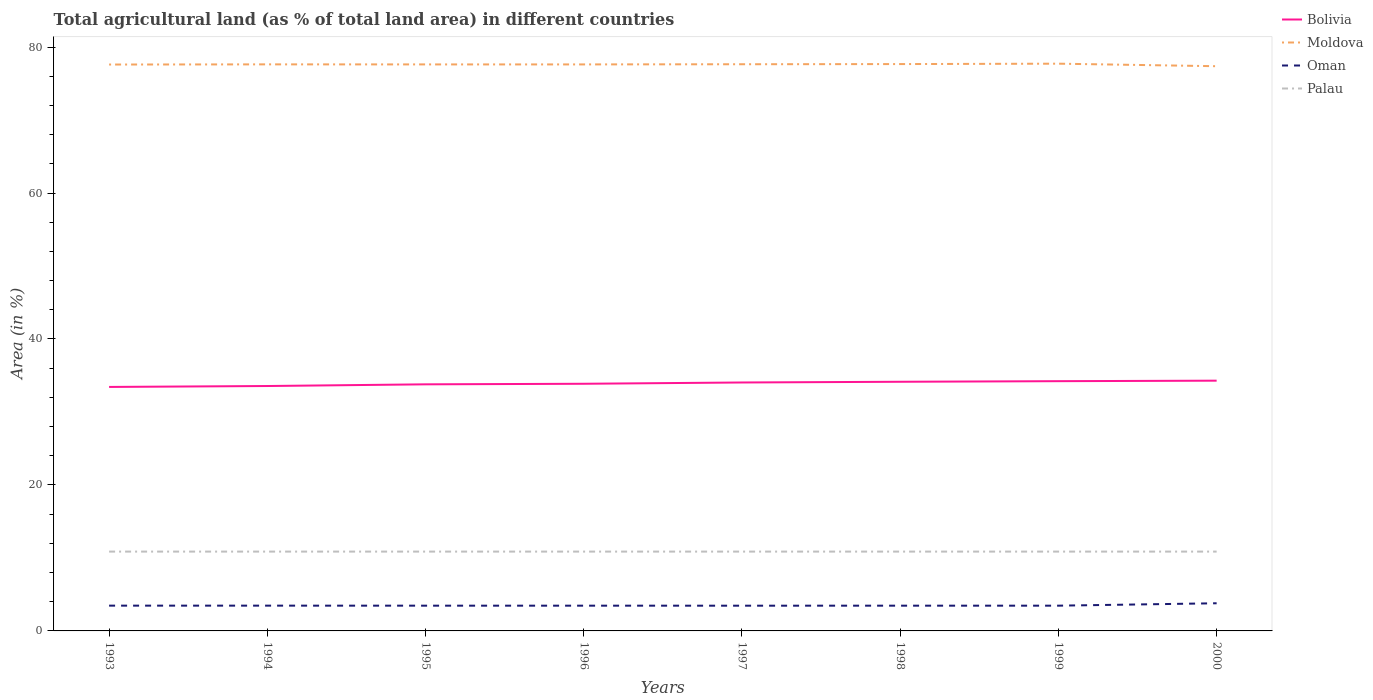Is the number of lines equal to the number of legend labels?
Ensure brevity in your answer.  Yes. Across all years, what is the maximum percentage of agricultural land in Bolivia?
Make the answer very short. 33.43. In which year was the percentage of agricultural land in Moldova maximum?
Offer a terse response. 2000. What is the total percentage of agricultural land in Oman in the graph?
Provide a short and direct response. -0. What is the difference between the highest and the second highest percentage of agricultural land in Moldova?
Provide a short and direct response. 0.35. Is the percentage of agricultural land in Bolivia strictly greater than the percentage of agricultural land in Palau over the years?
Your response must be concise. No. How many lines are there?
Give a very brief answer. 4. How many years are there in the graph?
Provide a short and direct response. 8. What is the difference between two consecutive major ticks on the Y-axis?
Keep it short and to the point. 20. Are the values on the major ticks of Y-axis written in scientific E-notation?
Provide a short and direct response. No. Where does the legend appear in the graph?
Provide a succinct answer. Top right. How are the legend labels stacked?
Ensure brevity in your answer.  Vertical. What is the title of the graph?
Keep it short and to the point. Total agricultural land (as % of total land area) in different countries. Does "Latin America(all income levels)" appear as one of the legend labels in the graph?
Your answer should be compact. No. What is the label or title of the X-axis?
Your response must be concise. Years. What is the label or title of the Y-axis?
Offer a terse response. Area (in %). What is the Area (in %) in Bolivia in 1993?
Give a very brief answer. 33.43. What is the Area (in %) in Moldova in 1993?
Your answer should be compact. 77.6. What is the Area (in %) of Oman in 1993?
Offer a very short reply. 3.46. What is the Area (in %) of Palau in 1993?
Offer a terse response. 10.87. What is the Area (in %) in Bolivia in 1994?
Ensure brevity in your answer.  33.56. What is the Area (in %) in Moldova in 1994?
Your answer should be compact. 77.63. What is the Area (in %) of Oman in 1994?
Ensure brevity in your answer.  3.46. What is the Area (in %) of Palau in 1994?
Offer a terse response. 10.87. What is the Area (in %) in Bolivia in 1995?
Your answer should be very brief. 33.79. What is the Area (in %) of Moldova in 1995?
Give a very brief answer. 77.62. What is the Area (in %) in Oman in 1995?
Provide a short and direct response. 3.46. What is the Area (in %) in Palau in 1995?
Offer a very short reply. 10.87. What is the Area (in %) of Bolivia in 1996?
Keep it short and to the point. 33.86. What is the Area (in %) of Moldova in 1996?
Your answer should be very brief. 77.62. What is the Area (in %) of Oman in 1996?
Offer a very short reply. 3.46. What is the Area (in %) of Palau in 1996?
Provide a short and direct response. 10.87. What is the Area (in %) of Bolivia in 1997?
Your answer should be very brief. 34.04. What is the Area (in %) of Moldova in 1997?
Offer a terse response. 77.64. What is the Area (in %) of Oman in 1997?
Offer a very short reply. 3.46. What is the Area (in %) in Palau in 1997?
Give a very brief answer. 10.87. What is the Area (in %) of Bolivia in 1998?
Give a very brief answer. 34.14. What is the Area (in %) of Moldova in 1998?
Keep it short and to the point. 77.67. What is the Area (in %) in Oman in 1998?
Offer a terse response. 3.46. What is the Area (in %) in Palau in 1998?
Keep it short and to the point. 10.87. What is the Area (in %) in Bolivia in 1999?
Your answer should be very brief. 34.22. What is the Area (in %) of Moldova in 1999?
Provide a succinct answer. 77.72. What is the Area (in %) in Oman in 1999?
Make the answer very short. 3.46. What is the Area (in %) in Palau in 1999?
Give a very brief answer. 10.87. What is the Area (in %) of Bolivia in 2000?
Provide a succinct answer. 34.29. What is the Area (in %) of Moldova in 2000?
Your answer should be very brief. 77.37. What is the Area (in %) of Oman in 2000?
Offer a very short reply. 3.79. What is the Area (in %) in Palau in 2000?
Provide a succinct answer. 10.87. Across all years, what is the maximum Area (in %) of Bolivia?
Offer a very short reply. 34.29. Across all years, what is the maximum Area (in %) of Moldova?
Your answer should be compact. 77.72. Across all years, what is the maximum Area (in %) of Oman?
Keep it short and to the point. 3.79. Across all years, what is the maximum Area (in %) of Palau?
Offer a terse response. 10.87. Across all years, what is the minimum Area (in %) of Bolivia?
Make the answer very short. 33.43. Across all years, what is the minimum Area (in %) in Moldova?
Keep it short and to the point. 77.37. Across all years, what is the minimum Area (in %) in Oman?
Your answer should be compact. 3.46. Across all years, what is the minimum Area (in %) in Palau?
Your answer should be very brief. 10.87. What is the total Area (in %) in Bolivia in the graph?
Offer a very short reply. 271.32. What is the total Area (in %) in Moldova in the graph?
Your answer should be compact. 620.87. What is the total Area (in %) of Oman in the graph?
Provide a succinct answer. 28.02. What is the total Area (in %) of Palau in the graph?
Your answer should be compact. 86.96. What is the difference between the Area (in %) in Bolivia in 1993 and that in 1994?
Keep it short and to the point. -0.13. What is the difference between the Area (in %) of Moldova in 1993 and that in 1994?
Keep it short and to the point. -0.02. What is the difference between the Area (in %) of Palau in 1993 and that in 1994?
Offer a very short reply. 0. What is the difference between the Area (in %) in Bolivia in 1993 and that in 1995?
Your answer should be compact. -0.36. What is the difference between the Area (in %) of Moldova in 1993 and that in 1995?
Give a very brief answer. -0.02. What is the difference between the Area (in %) of Oman in 1993 and that in 1995?
Offer a very short reply. 0. What is the difference between the Area (in %) of Palau in 1993 and that in 1995?
Make the answer very short. 0. What is the difference between the Area (in %) in Bolivia in 1993 and that in 1996?
Offer a terse response. -0.43. What is the difference between the Area (in %) of Moldova in 1993 and that in 1996?
Keep it short and to the point. -0.02. What is the difference between the Area (in %) of Oman in 1993 and that in 1996?
Provide a succinct answer. 0. What is the difference between the Area (in %) of Bolivia in 1993 and that in 1997?
Keep it short and to the point. -0.61. What is the difference between the Area (in %) in Moldova in 1993 and that in 1997?
Your answer should be very brief. -0.04. What is the difference between the Area (in %) in Oman in 1993 and that in 1997?
Give a very brief answer. 0.01. What is the difference between the Area (in %) in Palau in 1993 and that in 1997?
Your response must be concise. 0. What is the difference between the Area (in %) of Bolivia in 1993 and that in 1998?
Make the answer very short. -0.71. What is the difference between the Area (in %) in Moldova in 1993 and that in 1998?
Ensure brevity in your answer.  -0.06. What is the difference between the Area (in %) of Oman in 1993 and that in 1998?
Offer a terse response. 0. What is the difference between the Area (in %) in Palau in 1993 and that in 1998?
Ensure brevity in your answer.  0. What is the difference between the Area (in %) in Bolivia in 1993 and that in 1999?
Provide a short and direct response. -0.79. What is the difference between the Area (in %) of Moldova in 1993 and that in 1999?
Make the answer very short. -0.12. What is the difference between the Area (in %) in Oman in 1993 and that in 1999?
Your answer should be compact. 0. What is the difference between the Area (in %) in Palau in 1993 and that in 1999?
Keep it short and to the point. 0. What is the difference between the Area (in %) of Bolivia in 1993 and that in 2000?
Your response must be concise. -0.86. What is the difference between the Area (in %) of Moldova in 1993 and that in 2000?
Ensure brevity in your answer.  0.23. What is the difference between the Area (in %) in Oman in 1993 and that in 2000?
Make the answer very short. -0.33. What is the difference between the Area (in %) of Palau in 1993 and that in 2000?
Offer a terse response. 0. What is the difference between the Area (in %) in Bolivia in 1994 and that in 1995?
Your response must be concise. -0.23. What is the difference between the Area (in %) of Moldova in 1994 and that in 1995?
Your response must be concise. 0.01. What is the difference between the Area (in %) of Oman in 1994 and that in 1995?
Your response must be concise. 0. What is the difference between the Area (in %) of Bolivia in 1994 and that in 1996?
Make the answer very short. -0.31. What is the difference between the Area (in %) in Moldova in 1994 and that in 1996?
Your answer should be compact. 0.01. What is the difference between the Area (in %) of Oman in 1994 and that in 1996?
Your answer should be very brief. 0. What is the difference between the Area (in %) in Bolivia in 1994 and that in 1997?
Make the answer very short. -0.48. What is the difference between the Area (in %) in Moldova in 1994 and that in 1997?
Ensure brevity in your answer.  -0.02. What is the difference between the Area (in %) in Oman in 1994 and that in 1997?
Provide a short and direct response. 0.01. What is the difference between the Area (in %) in Palau in 1994 and that in 1997?
Your answer should be very brief. 0. What is the difference between the Area (in %) of Bolivia in 1994 and that in 1998?
Keep it short and to the point. -0.58. What is the difference between the Area (in %) in Moldova in 1994 and that in 1998?
Give a very brief answer. -0.04. What is the difference between the Area (in %) of Oman in 1994 and that in 1998?
Provide a succinct answer. 0. What is the difference between the Area (in %) in Palau in 1994 and that in 1998?
Your response must be concise. 0. What is the difference between the Area (in %) of Bolivia in 1994 and that in 1999?
Provide a succinct answer. -0.66. What is the difference between the Area (in %) of Moldova in 1994 and that in 1999?
Provide a succinct answer. -0.09. What is the difference between the Area (in %) in Oman in 1994 and that in 1999?
Your response must be concise. 0. What is the difference between the Area (in %) of Bolivia in 1994 and that in 2000?
Your answer should be compact. -0.73. What is the difference between the Area (in %) in Moldova in 1994 and that in 2000?
Provide a short and direct response. 0.25. What is the difference between the Area (in %) in Oman in 1994 and that in 2000?
Your answer should be compact. -0.33. What is the difference between the Area (in %) in Palau in 1994 and that in 2000?
Your answer should be compact. 0. What is the difference between the Area (in %) in Bolivia in 1995 and that in 1996?
Your response must be concise. -0.08. What is the difference between the Area (in %) of Moldova in 1995 and that in 1996?
Ensure brevity in your answer.  0. What is the difference between the Area (in %) in Bolivia in 1995 and that in 1997?
Offer a terse response. -0.25. What is the difference between the Area (in %) in Moldova in 1995 and that in 1997?
Your answer should be very brief. -0.02. What is the difference between the Area (in %) in Oman in 1995 and that in 1997?
Keep it short and to the point. 0. What is the difference between the Area (in %) in Bolivia in 1995 and that in 1998?
Your answer should be compact. -0.35. What is the difference between the Area (in %) in Moldova in 1995 and that in 1998?
Your answer should be very brief. -0.05. What is the difference between the Area (in %) of Bolivia in 1995 and that in 1999?
Give a very brief answer. -0.43. What is the difference between the Area (in %) of Moldova in 1995 and that in 1999?
Offer a terse response. -0.1. What is the difference between the Area (in %) of Oman in 1995 and that in 1999?
Provide a short and direct response. 0. What is the difference between the Area (in %) in Bolivia in 1995 and that in 2000?
Offer a very short reply. -0.5. What is the difference between the Area (in %) in Moldova in 1995 and that in 2000?
Your answer should be very brief. 0.25. What is the difference between the Area (in %) of Oman in 1995 and that in 2000?
Provide a short and direct response. -0.33. What is the difference between the Area (in %) in Bolivia in 1996 and that in 1997?
Offer a terse response. -0.18. What is the difference between the Area (in %) in Moldova in 1996 and that in 1997?
Your answer should be very brief. -0.02. What is the difference between the Area (in %) of Oman in 1996 and that in 1997?
Your answer should be very brief. 0. What is the difference between the Area (in %) in Palau in 1996 and that in 1997?
Give a very brief answer. 0. What is the difference between the Area (in %) of Bolivia in 1996 and that in 1998?
Keep it short and to the point. -0.28. What is the difference between the Area (in %) in Moldova in 1996 and that in 1998?
Ensure brevity in your answer.  -0.05. What is the difference between the Area (in %) in Bolivia in 1996 and that in 1999?
Provide a succinct answer. -0.36. What is the difference between the Area (in %) of Moldova in 1996 and that in 1999?
Your answer should be compact. -0.1. What is the difference between the Area (in %) in Oman in 1996 and that in 1999?
Provide a short and direct response. 0. What is the difference between the Area (in %) in Palau in 1996 and that in 1999?
Offer a very short reply. 0. What is the difference between the Area (in %) in Bolivia in 1996 and that in 2000?
Provide a succinct answer. -0.42. What is the difference between the Area (in %) of Moldova in 1996 and that in 2000?
Keep it short and to the point. 0.25. What is the difference between the Area (in %) of Oman in 1996 and that in 2000?
Your answer should be compact. -0.33. What is the difference between the Area (in %) of Palau in 1996 and that in 2000?
Make the answer very short. 0. What is the difference between the Area (in %) of Bolivia in 1997 and that in 1998?
Your response must be concise. -0.1. What is the difference between the Area (in %) in Moldova in 1997 and that in 1998?
Your response must be concise. -0.02. What is the difference between the Area (in %) of Oman in 1997 and that in 1998?
Your answer should be compact. -0. What is the difference between the Area (in %) in Palau in 1997 and that in 1998?
Offer a very short reply. 0. What is the difference between the Area (in %) in Bolivia in 1997 and that in 1999?
Provide a succinct answer. -0.18. What is the difference between the Area (in %) of Moldova in 1997 and that in 1999?
Make the answer very short. -0.08. What is the difference between the Area (in %) in Oman in 1997 and that in 1999?
Give a very brief answer. -0. What is the difference between the Area (in %) of Palau in 1997 and that in 1999?
Offer a very short reply. 0. What is the difference between the Area (in %) in Bolivia in 1997 and that in 2000?
Ensure brevity in your answer.  -0.25. What is the difference between the Area (in %) of Moldova in 1997 and that in 2000?
Your answer should be very brief. 0.27. What is the difference between the Area (in %) in Oman in 1997 and that in 2000?
Your answer should be very brief. -0.33. What is the difference between the Area (in %) of Palau in 1997 and that in 2000?
Your answer should be compact. 0. What is the difference between the Area (in %) in Bolivia in 1998 and that in 1999?
Give a very brief answer. -0.08. What is the difference between the Area (in %) in Moldova in 1998 and that in 1999?
Keep it short and to the point. -0.05. What is the difference between the Area (in %) in Oman in 1998 and that in 1999?
Ensure brevity in your answer.  0. What is the difference between the Area (in %) of Palau in 1998 and that in 1999?
Keep it short and to the point. 0. What is the difference between the Area (in %) of Bolivia in 1998 and that in 2000?
Provide a succinct answer. -0.15. What is the difference between the Area (in %) in Moldova in 1998 and that in 2000?
Give a very brief answer. 0.29. What is the difference between the Area (in %) in Oman in 1998 and that in 2000?
Your response must be concise. -0.33. What is the difference between the Area (in %) in Palau in 1998 and that in 2000?
Offer a terse response. 0. What is the difference between the Area (in %) in Bolivia in 1999 and that in 2000?
Your answer should be compact. -0.07. What is the difference between the Area (in %) in Moldova in 1999 and that in 2000?
Give a very brief answer. 0.35. What is the difference between the Area (in %) of Oman in 1999 and that in 2000?
Offer a terse response. -0.33. What is the difference between the Area (in %) in Palau in 1999 and that in 2000?
Offer a very short reply. 0. What is the difference between the Area (in %) of Bolivia in 1993 and the Area (in %) of Moldova in 1994?
Offer a very short reply. -44.2. What is the difference between the Area (in %) in Bolivia in 1993 and the Area (in %) in Oman in 1994?
Provide a short and direct response. 29.96. What is the difference between the Area (in %) of Bolivia in 1993 and the Area (in %) of Palau in 1994?
Offer a terse response. 22.56. What is the difference between the Area (in %) of Moldova in 1993 and the Area (in %) of Oman in 1994?
Your answer should be compact. 74.14. What is the difference between the Area (in %) of Moldova in 1993 and the Area (in %) of Palau in 1994?
Offer a very short reply. 66.73. What is the difference between the Area (in %) of Oman in 1993 and the Area (in %) of Palau in 1994?
Ensure brevity in your answer.  -7.41. What is the difference between the Area (in %) of Bolivia in 1993 and the Area (in %) of Moldova in 1995?
Provide a short and direct response. -44.19. What is the difference between the Area (in %) in Bolivia in 1993 and the Area (in %) in Oman in 1995?
Provide a succinct answer. 29.97. What is the difference between the Area (in %) in Bolivia in 1993 and the Area (in %) in Palau in 1995?
Make the answer very short. 22.56. What is the difference between the Area (in %) of Moldova in 1993 and the Area (in %) of Oman in 1995?
Ensure brevity in your answer.  74.14. What is the difference between the Area (in %) in Moldova in 1993 and the Area (in %) in Palau in 1995?
Your answer should be very brief. 66.73. What is the difference between the Area (in %) in Oman in 1993 and the Area (in %) in Palau in 1995?
Keep it short and to the point. -7.41. What is the difference between the Area (in %) of Bolivia in 1993 and the Area (in %) of Moldova in 1996?
Offer a terse response. -44.19. What is the difference between the Area (in %) of Bolivia in 1993 and the Area (in %) of Oman in 1996?
Your response must be concise. 29.97. What is the difference between the Area (in %) of Bolivia in 1993 and the Area (in %) of Palau in 1996?
Keep it short and to the point. 22.56. What is the difference between the Area (in %) in Moldova in 1993 and the Area (in %) in Oman in 1996?
Your answer should be compact. 74.14. What is the difference between the Area (in %) in Moldova in 1993 and the Area (in %) in Palau in 1996?
Ensure brevity in your answer.  66.73. What is the difference between the Area (in %) of Oman in 1993 and the Area (in %) of Palau in 1996?
Your answer should be very brief. -7.41. What is the difference between the Area (in %) of Bolivia in 1993 and the Area (in %) of Moldova in 1997?
Offer a very short reply. -44.21. What is the difference between the Area (in %) of Bolivia in 1993 and the Area (in %) of Oman in 1997?
Offer a terse response. 29.97. What is the difference between the Area (in %) in Bolivia in 1993 and the Area (in %) in Palau in 1997?
Your response must be concise. 22.56. What is the difference between the Area (in %) of Moldova in 1993 and the Area (in %) of Oman in 1997?
Offer a very short reply. 74.15. What is the difference between the Area (in %) of Moldova in 1993 and the Area (in %) of Palau in 1997?
Offer a terse response. 66.73. What is the difference between the Area (in %) of Oman in 1993 and the Area (in %) of Palau in 1997?
Keep it short and to the point. -7.41. What is the difference between the Area (in %) in Bolivia in 1993 and the Area (in %) in Moldova in 1998?
Offer a very short reply. -44.24. What is the difference between the Area (in %) of Bolivia in 1993 and the Area (in %) of Oman in 1998?
Your response must be concise. 29.97. What is the difference between the Area (in %) in Bolivia in 1993 and the Area (in %) in Palau in 1998?
Your response must be concise. 22.56. What is the difference between the Area (in %) of Moldova in 1993 and the Area (in %) of Oman in 1998?
Provide a succinct answer. 74.14. What is the difference between the Area (in %) in Moldova in 1993 and the Area (in %) in Palau in 1998?
Provide a short and direct response. 66.73. What is the difference between the Area (in %) in Oman in 1993 and the Area (in %) in Palau in 1998?
Your response must be concise. -7.41. What is the difference between the Area (in %) in Bolivia in 1993 and the Area (in %) in Moldova in 1999?
Your answer should be compact. -44.29. What is the difference between the Area (in %) in Bolivia in 1993 and the Area (in %) in Oman in 1999?
Make the answer very short. 29.97. What is the difference between the Area (in %) of Bolivia in 1993 and the Area (in %) of Palau in 1999?
Offer a very short reply. 22.56. What is the difference between the Area (in %) in Moldova in 1993 and the Area (in %) in Oman in 1999?
Provide a succinct answer. 74.14. What is the difference between the Area (in %) of Moldova in 1993 and the Area (in %) of Palau in 1999?
Make the answer very short. 66.73. What is the difference between the Area (in %) of Oman in 1993 and the Area (in %) of Palau in 1999?
Your answer should be very brief. -7.41. What is the difference between the Area (in %) in Bolivia in 1993 and the Area (in %) in Moldova in 2000?
Your answer should be very brief. -43.94. What is the difference between the Area (in %) of Bolivia in 1993 and the Area (in %) of Oman in 2000?
Provide a succinct answer. 29.64. What is the difference between the Area (in %) in Bolivia in 1993 and the Area (in %) in Palau in 2000?
Give a very brief answer. 22.56. What is the difference between the Area (in %) of Moldova in 1993 and the Area (in %) of Oman in 2000?
Keep it short and to the point. 73.81. What is the difference between the Area (in %) in Moldova in 1993 and the Area (in %) in Palau in 2000?
Your response must be concise. 66.73. What is the difference between the Area (in %) in Oman in 1993 and the Area (in %) in Palau in 2000?
Give a very brief answer. -7.41. What is the difference between the Area (in %) of Bolivia in 1994 and the Area (in %) of Moldova in 1995?
Provide a succinct answer. -44.06. What is the difference between the Area (in %) in Bolivia in 1994 and the Area (in %) in Oman in 1995?
Offer a terse response. 30.1. What is the difference between the Area (in %) in Bolivia in 1994 and the Area (in %) in Palau in 1995?
Give a very brief answer. 22.69. What is the difference between the Area (in %) of Moldova in 1994 and the Area (in %) of Oman in 1995?
Ensure brevity in your answer.  74.17. What is the difference between the Area (in %) of Moldova in 1994 and the Area (in %) of Palau in 1995?
Provide a short and direct response. 66.76. What is the difference between the Area (in %) of Oman in 1994 and the Area (in %) of Palau in 1995?
Your answer should be very brief. -7.41. What is the difference between the Area (in %) of Bolivia in 1994 and the Area (in %) of Moldova in 1996?
Provide a short and direct response. -44.06. What is the difference between the Area (in %) in Bolivia in 1994 and the Area (in %) in Oman in 1996?
Your answer should be very brief. 30.1. What is the difference between the Area (in %) of Bolivia in 1994 and the Area (in %) of Palau in 1996?
Your response must be concise. 22.69. What is the difference between the Area (in %) in Moldova in 1994 and the Area (in %) in Oman in 1996?
Provide a succinct answer. 74.17. What is the difference between the Area (in %) of Moldova in 1994 and the Area (in %) of Palau in 1996?
Your response must be concise. 66.76. What is the difference between the Area (in %) in Oman in 1994 and the Area (in %) in Palau in 1996?
Make the answer very short. -7.41. What is the difference between the Area (in %) in Bolivia in 1994 and the Area (in %) in Moldova in 1997?
Your answer should be compact. -44.09. What is the difference between the Area (in %) in Bolivia in 1994 and the Area (in %) in Oman in 1997?
Your answer should be very brief. 30.1. What is the difference between the Area (in %) in Bolivia in 1994 and the Area (in %) in Palau in 1997?
Offer a very short reply. 22.69. What is the difference between the Area (in %) in Moldova in 1994 and the Area (in %) in Oman in 1997?
Provide a succinct answer. 74.17. What is the difference between the Area (in %) of Moldova in 1994 and the Area (in %) of Palau in 1997?
Make the answer very short. 66.76. What is the difference between the Area (in %) in Oman in 1994 and the Area (in %) in Palau in 1997?
Provide a succinct answer. -7.41. What is the difference between the Area (in %) of Bolivia in 1994 and the Area (in %) of Moldova in 1998?
Your answer should be compact. -44.11. What is the difference between the Area (in %) in Bolivia in 1994 and the Area (in %) in Oman in 1998?
Your response must be concise. 30.1. What is the difference between the Area (in %) in Bolivia in 1994 and the Area (in %) in Palau in 1998?
Your answer should be very brief. 22.69. What is the difference between the Area (in %) of Moldova in 1994 and the Area (in %) of Oman in 1998?
Make the answer very short. 74.17. What is the difference between the Area (in %) of Moldova in 1994 and the Area (in %) of Palau in 1998?
Your answer should be very brief. 66.76. What is the difference between the Area (in %) in Oman in 1994 and the Area (in %) in Palau in 1998?
Offer a terse response. -7.41. What is the difference between the Area (in %) of Bolivia in 1994 and the Area (in %) of Moldova in 1999?
Give a very brief answer. -44.16. What is the difference between the Area (in %) of Bolivia in 1994 and the Area (in %) of Oman in 1999?
Keep it short and to the point. 30.1. What is the difference between the Area (in %) of Bolivia in 1994 and the Area (in %) of Palau in 1999?
Provide a succinct answer. 22.69. What is the difference between the Area (in %) of Moldova in 1994 and the Area (in %) of Oman in 1999?
Your answer should be very brief. 74.17. What is the difference between the Area (in %) in Moldova in 1994 and the Area (in %) in Palau in 1999?
Your response must be concise. 66.76. What is the difference between the Area (in %) of Oman in 1994 and the Area (in %) of Palau in 1999?
Your answer should be very brief. -7.41. What is the difference between the Area (in %) in Bolivia in 1994 and the Area (in %) in Moldova in 2000?
Keep it short and to the point. -43.82. What is the difference between the Area (in %) in Bolivia in 1994 and the Area (in %) in Oman in 2000?
Give a very brief answer. 29.77. What is the difference between the Area (in %) in Bolivia in 1994 and the Area (in %) in Palau in 2000?
Offer a terse response. 22.69. What is the difference between the Area (in %) of Moldova in 1994 and the Area (in %) of Oman in 2000?
Make the answer very short. 73.84. What is the difference between the Area (in %) in Moldova in 1994 and the Area (in %) in Palau in 2000?
Your answer should be compact. 66.76. What is the difference between the Area (in %) of Oman in 1994 and the Area (in %) of Palau in 2000?
Your answer should be very brief. -7.41. What is the difference between the Area (in %) of Bolivia in 1995 and the Area (in %) of Moldova in 1996?
Offer a terse response. -43.83. What is the difference between the Area (in %) of Bolivia in 1995 and the Area (in %) of Oman in 1996?
Provide a short and direct response. 30.33. What is the difference between the Area (in %) of Bolivia in 1995 and the Area (in %) of Palau in 1996?
Provide a succinct answer. 22.92. What is the difference between the Area (in %) in Moldova in 1995 and the Area (in %) in Oman in 1996?
Give a very brief answer. 74.16. What is the difference between the Area (in %) of Moldova in 1995 and the Area (in %) of Palau in 1996?
Provide a succinct answer. 66.75. What is the difference between the Area (in %) in Oman in 1995 and the Area (in %) in Palau in 1996?
Your answer should be very brief. -7.41. What is the difference between the Area (in %) of Bolivia in 1995 and the Area (in %) of Moldova in 1997?
Your response must be concise. -43.86. What is the difference between the Area (in %) in Bolivia in 1995 and the Area (in %) in Oman in 1997?
Your answer should be compact. 30.33. What is the difference between the Area (in %) of Bolivia in 1995 and the Area (in %) of Palau in 1997?
Make the answer very short. 22.92. What is the difference between the Area (in %) of Moldova in 1995 and the Area (in %) of Oman in 1997?
Provide a succinct answer. 74.16. What is the difference between the Area (in %) in Moldova in 1995 and the Area (in %) in Palau in 1997?
Offer a very short reply. 66.75. What is the difference between the Area (in %) in Oman in 1995 and the Area (in %) in Palau in 1997?
Offer a terse response. -7.41. What is the difference between the Area (in %) in Bolivia in 1995 and the Area (in %) in Moldova in 1998?
Make the answer very short. -43.88. What is the difference between the Area (in %) in Bolivia in 1995 and the Area (in %) in Oman in 1998?
Give a very brief answer. 30.33. What is the difference between the Area (in %) of Bolivia in 1995 and the Area (in %) of Palau in 1998?
Your answer should be compact. 22.92. What is the difference between the Area (in %) in Moldova in 1995 and the Area (in %) in Oman in 1998?
Keep it short and to the point. 74.16. What is the difference between the Area (in %) in Moldova in 1995 and the Area (in %) in Palau in 1998?
Ensure brevity in your answer.  66.75. What is the difference between the Area (in %) in Oman in 1995 and the Area (in %) in Palau in 1998?
Ensure brevity in your answer.  -7.41. What is the difference between the Area (in %) of Bolivia in 1995 and the Area (in %) of Moldova in 1999?
Ensure brevity in your answer.  -43.93. What is the difference between the Area (in %) in Bolivia in 1995 and the Area (in %) in Oman in 1999?
Ensure brevity in your answer.  30.33. What is the difference between the Area (in %) in Bolivia in 1995 and the Area (in %) in Palau in 1999?
Offer a very short reply. 22.92. What is the difference between the Area (in %) in Moldova in 1995 and the Area (in %) in Oman in 1999?
Make the answer very short. 74.16. What is the difference between the Area (in %) in Moldova in 1995 and the Area (in %) in Palau in 1999?
Your response must be concise. 66.75. What is the difference between the Area (in %) of Oman in 1995 and the Area (in %) of Palau in 1999?
Provide a short and direct response. -7.41. What is the difference between the Area (in %) in Bolivia in 1995 and the Area (in %) in Moldova in 2000?
Keep it short and to the point. -43.59. What is the difference between the Area (in %) in Bolivia in 1995 and the Area (in %) in Oman in 2000?
Keep it short and to the point. 30. What is the difference between the Area (in %) of Bolivia in 1995 and the Area (in %) of Palau in 2000?
Provide a short and direct response. 22.92. What is the difference between the Area (in %) in Moldova in 1995 and the Area (in %) in Oman in 2000?
Your answer should be very brief. 73.83. What is the difference between the Area (in %) in Moldova in 1995 and the Area (in %) in Palau in 2000?
Ensure brevity in your answer.  66.75. What is the difference between the Area (in %) in Oman in 1995 and the Area (in %) in Palau in 2000?
Keep it short and to the point. -7.41. What is the difference between the Area (in %) of Bolivia in 1996 and the Area (in %) of Moldova in 1997?
Make the answer very short. -43.78. What is the difference between the Area (in %) in Bolivia in 1996 and the Area (in %) in Oman in 1997?
Ensure brevity in your answer.  30.41. What is the difference between the Area (in %) of Bolivia in 1996 and the Area (in %) of Palau in 1997?
Ensure brevity in your answer.  22.99. What is the difference between the Area (in %) of Moldova in 1996 and the Area (in %) of Oman in 1997?
Ensure brevity in your answer.  74.16. What is the difference between the Area (in %) in Moldova in 1996 and the Area (in %) in Palau in 1997?
Give a very brief answer. 66.75. What is the difference between the Area (in %) of Oman in 1996 and the Area (in %) of Palau in 1997?
Offer a very short reply. -7.41. What is the difference between the Area (in %) in Bolivia in 1996 and the Area (in %) in Moldova in 1998?
Keep it short and to the point. -43.8. What is the difference between the Area (in %) of Bolivia in 1996 and the Area (in %) of Oman in 1998?
Offer a very short reply. 30.4. What is the difference between the Area (in %) of Bolivia in 1996 and the Area (in %) of Palau in 1998?
Your answer should be very brief. 22.99. What is the difference between the Area (in %) in Moldova in 1996 and the Area (in %) in Oman in 1998?
Your answer should be very brief. 74.16. What is the difference between the Area (in %) of Moldova in 1996 and the Area (in %) of Palau in 1998?
Give a very brief answer. 66.75. What is the difference between the Area (in %) of Oman in 1996 and the Area (in %) of Palau in 1998?
Your response must be concise. -7.41. What is the difference between the Area (in %) in Bolivia in 1996 and the Area (in %) in Moldova in 1999?
Your answer should be very brief. -43.86. What is the difference between the Area (in %) in Bolivia in 1996 and the Area (in %) in Oman in 1999?
Your response must be concise. 30.4. What is the difference between the Area (in %) of Bolivia in 1996 and the Area (in %) of Palau in 1999?
Ensure brevity in your answer.  22.99. What is the difference between the Area (in %) in Moldova in 1996 and the Area (in %) in Oman in 1999?
Your answer should be very brief. 74.16. What is the difference between the Area (in %) in Moldova in 1996 and the Area (in %) in Palau in 1999?
Keep it short and to the point. 66.75. What is the difference between the Area (in %) in Oman in 1996 and the Area (in %) in Palau in 1999?
Your response must be concise. -7.41. What is the difference between the Area (in %) in Bolivia in 1996 and the Area (in %) in Moldova in 2000?
Your answer should be very brief. -43.51. What is the difference between the Area (in %) of Bolivia in 1996 and the Area (in %) of Oman in 2000?
Provide a succinct answer. 30.07. What is the difference between the Area (in %) of Bolivia in 1996 and the Area (in %) of Palau in 2000?
Offer a terse response. 22.99. What is the difference between the Area (in %) in Moldova in 1996 and the Area (in %) in Oman in 2000?
Ensure brevity in your answer.  73.83. What is the difference between the Area (in %) of Moldova in 1996 and the Area (in %) of Palau in 2000?
Ensure brevity in your answer.  66.75. What is the difference between the Area (in %) of Oman in 1996 and the Area (in %) of Palau in 2000?
Provide a short and direct response. -7.41. What is the difference between the Area (in %) in Bolivia in 1997 and the Area (in %) in Moldova in 1998?
Make the answer very short. -43.63. What is the difference between the Area (in %) of Bolivia in 1997 and the Area (in %) of Oman in 1998?
Provide a succinct answer. 30.58. What is the difference between the Area (in %) in Bolivia in 1997 and the Area (in %) in Palau in 1998?
Give a very brief answer. 23.17. What is the difference between the Area (in %) of Moldova in 1997 and the Area (in %) of Oman in 1998?
Give a very brief answer. 74.18. What is the difference between the Area (in %) in Moldova in 1997 and the Area (in %) in Palau in 1998?
Your answer should be compact. 66.77. What is the difference between the Area (in %) in Oman in 1997 and the Area (in %) in Palau in 1998?
Ensure brevity in your answer.  -7.41. What is the difference between the Area (in %) in Bolivia in 1997 and the Area (in %) in Moldova in 1999?
Give a very brief answer. -43.68. What is the difference between the Area (in %) in Bolivia in 1997 and the Area (in %) in Oman in 1999?
Keep it short and to the point. 30.58. What is the difference between the Area (in %) of Bolivia in 1997 and the Area (in %) of Palau in 1999?
Offer a terse response. 23.17. What is the difference between the Area (in %) in Moldova in 1997 and the Area (in %) in Oman in 1999?
Offer a very short reply. 74.18. What is the difference between the Area (in %) in Moldova in 1997 and the Area (in %) in Palau in 1999?
Your answer should be compact. 66.77. What is the difference between the Area (in %) in Oman in 1997 and the Area (in %) in Palau in 1999?
Give a very brief answer. -7.41. What is the difference between the Area (in %) of Bolivia in 1997 and the Area (in %) of Moldova in 2000?
Make the answer very short. -43.33. What is the difference between the Area (in %) of Bolivia in 1997 and the Area (in %) of Oman in 2000?
Your answer should be compact. 30.25. What is the difference between the Area (in %) in Bolivia in 1997 and the Area (in %) in Palau in 2000?
Your response must be concise. 23.17. What is the difference between the Area (in %) in Moldova in 1997 and the Area (in %) in Oman in 2000?
Your answer should be compact. 73.85. What is the difference between the Area (in %) of Moldova in 1997 and the Area (in %) of Palau in 2000?
Keep it short and to the point. 66.77. What is the difference between the Area (in %) in Oman in 1997 and the Area (in %) in Palau in 2000?
Offer a very short reply. -7.41. What is the difference between the Area (in %) of Bolivia in 1998 and the Area (in %) of Moldova in 1999?
Give a very brief answer. -43.58. What is the difference between the Area (in %) in Bolivia in 1998 and the Area (in %) in Oman in 1999?
Offer a very short reply. 30.68. What is the difference between the Area (in %) of Bolivia in 1998 and the Area (in %) of Palau in 1999?
Offer a terse response. 23.27. What is the difference between the Area (in %) in Moldova in 1998 and the Area (in %) in Oman in 1999?
Give a very brief answer. 74.21. What is the difference between the Area (in %) in Moldova in 1998 and the Area (in %) in Palau in 1999?
Keep it short and to the point. 66.8. What is the difference between the Area (in %) of Oman in 1998 and the Area (in %) of Palau in 1999?
Your response must be concise. -7.41. What is the difference between the Area (in %) of Bolivia in 1998 and the Area (in %) of Moldova in 2000?
Offer a very short reply. -43.23. What is the difference between the Area (in %) in Bolivia in 1998 and the Area (in %) in Oman in 2000?
Provide a succinct answer. 30.35. What is the difference between the Area (in %) in Bolivia in 1998 and the Area (in %) in Palau in 2000?
Your response must be concise. 23.27. What is the difference between the Area (in %) in Moldova in 1998 and the Area (in %) in Oman in 2000?
Make the answer very short. 73.88. What is the difference between the Area (in %) in Moldova in 1998 and the Area (in %) in Palau in 2000?
Your response must be concise. 66.8. What is the difference between the Area (in %) in Oman in 1998 and the Area (in %) in Palau in 2000?
Provide a short and direct response. -7.41. What is the difference between the Area (in %) of Bolivia in 1999 and the Area (in %) of Moldova in 2000?
Offer a very short reply. -43.15. What is the difference between the Area (in %) of Bolivia in 1999 and the Area (in %) of Oman in 2000?
Offer a terse response. 30.43. What is the difference between the Area (in %) in Bolivia in 1999 and the Area (in %) in Palau in 2000?
Keep it short and to the point. 23.35. What is the difference between the Area (in %) of Moldova in 1999 and the Area (in %) of Oman in 2000?
Offer a very short reply. 73.93. What is the difference between the Area (in %) of Moldova in 1999 and the Area (in %) of Palau in 2000?
Your answer should be very brief. 66.85. What is the difference between the Area (in %) in Oman in 1999 and the Area (in %) in Palau in 2000?
Your answer should be compact. -7.41. What is the average Area (in %) in Bolivia per year?
Your answer should be compact. 33.91. What is the average Area (in %) in Moldova per year?
Provide a succinct answer. 77.61. What is the average Area (in %) in Oman per year?
Give a very brief answer. 3.5. What is the average Area (in %) of Palau per year?
Your answer should be compact. 10.87. In the year 1993, what is the difference between the Area (in %) in Bolivia and Area (in %) in Moldova?
Your response must be concise. -44.17. In the year 1993, what is the difference between the Area (in %) in Bolivia and Area (in %) in Oman?
Keep it short and to the point. 29.96. In the year 1993, what is the difference between the Area (in %) of Bolivia and Area (in %) of Palau?
Provide a succinct answer. 22.56. In the year 1993, what is the difference between the Area (in %) in Moldova and Area (in %) in Oman?
Provide a succinct answer. 74.14. In the year 1993, what is the difference between the Area (in %) in Moldova and Area (in %) in Palau?
Provide a succinct answer. 66.73. In the year 1993, what is the difference between the Area (in %) of Oman and Area (in %) of Palau?
Your response must be concise. -7.41. In the year 1994, what is the difference between the Area (in %) in Bolivia and Area (in %) in Moldova?
Your answer should be compact. -44.07. In the year 1994, what is the difference between the Area (in %) in Bolivia and Area (in %) in Oman?
Offer a very short reply. 30.09. In the year 1994, what is the difference between the Area (in %) in Bolivia and Area (in %) in Palau?
Your response must be concise. 22.69. In the year 1994, what is the difference between the Area (in %) in Moldova and Area (in %) in Oman?
Give a very brief answer. 74.16. In the year 1994, what is the difference between the Area (in %) in Moldova and Area (in %) in Palau?
Ensure brevity in your answer.  66.76. In the year 1994, what is the difference between the Area (in %) of Oman and Area (in %) of Palau?
Give a very brief answer. -7.41. In the year 1995, what is the difference between the Area (in %) in Bolivia and Area (in %) in Moldova?
Your answer should be compact. -43.83. In the year 1995, what is the difference between the Area (in %) in Bolivia and Area (in %) in Oman?
Your response must be concise. 30.33. In the year 1995, what is the difference between the Area (in %) of Bolivia and Area (in %) of Palau?
Keep it short and to the point. 22.92. In the year 1995, what is the difference between the Area (in %) in Moldova and Area (in %) in Oman?
Ensure brevity in your answer.  74.16. In the year 1995, what is the difference between the Area (in %) in Moldova and Area (in %) in Palau?
Your response must be concise. 66.75. In the year 1995, what is the difference between the Area (in %) in Oman and Area (in %) in Palau?
Your response must be concise. -7.41. In the year 1996, what is the difference between the Area (in %) in Bolivia and Area (in %) in Moldova?
Give a very brief answer. -43.76. In the year 1996, what is the difference between the Area (in %) in Bolivia and Area (in %) in Oman?
Make the answer very short. 30.4. In the year 1996, what is the difference between the Area (in %) in Bolivia and Area (in %) in Palau?
Your answer should be very brief. 22.99. In the year 1996, what is the difference between the Area (in %) in Moldova and Area (in %) in Oman?
Keep it short and to the point. 74.16. In the year 1996, what is the difference between the Area (in %) of Moldova and Area (in %) of Palau?
Your answer should be compact. 66.75. In the year 1996, what is the difference between the Area (in %) in Oman and Area (in %) in Palau?
Ensure brevity in your answer.  -7.41. In the year 1997, what is the difference between the Area (in %) in Bolivia and Area (in %) in Moldova?
Your answer should be very brief. -43.6. In the year 1997, what is the difference between the Area (in %) of Bolivia and Area (in %) of Oman?
Keep it short and to the point. 30.58. In the year 1997, what is the difference between the Area (in %) of Bolivia and Area (in %) of Palau?
Give a very brief answer. 23.17. In the year 1997, what is the difference between the Area (in %) in Moldova and Area (in %) in Oman?
Your answer should be compact. 74.19. In the year 1997, what is the difference between the Area (in %) of Moldova and Area (in %) of Palau?
Your response must be concise. 66.77. In the year 1997, what is the difference between the Area (in %) in Oman and Area (in %) in Palau?
Provide a short and direct response. -7.41. In the year 1998, what is the difference between the Area (in %) in Bolivia and Area (in %) in Moldova?
Offer a very short reply. -43.53. In the year 1998, what is the difference between the Area (in %) of Bolivia and Area (in %) of Oman?
Make the answer very short. 30.68. In the year 1998, what is the difference between the Area (in %) in Bolivia and Area (in %) in Palau?
Ensure brevity in your answer.  23.27. In the year 1998, what is the difference between the Area (in %) of Moldova and Area (in %) of Oman?
Ensure brevity in your answer.  74.21. In the year 1998, what is the difference between the Area (in %) of Moldova and Area (in %) of Palau?
Offer a very short reply. 66.8. In the year 1998, what is the difference between the Area (in %) in Oman and Area (in %) in Palau?
Make the answer very short. -7.41. In the year 1999, what is the difference between the Area (in %) in Bolivia and Area (in %) in Moldova?
Provide a succinct answer. -43.5. In the year 1999, what is the difference between the Area (in %) in Bolivia and Area (in %) in Oman?
Keep it short and to the point. 30.76. In the year 1999, what is the difference between the Area (in %) of Bolivia and Area (in %) of Palau?
Ensure brevity in your answer.  23.35. In the year 1999, what is the difference between the Area (in %) of Moldova and Area (in %) of Oman?
Offer a very short reply. 74.26. In the year 1999, what is the difference between the Area (in %) in Moldova and Area (in %) in Palau?
Make the answer very short. 66.85. In the year 1999, what is the difference between the Area (in %) in Oman and Area (in %) in Palau?
Provide a short and direct response. -7.41. In the year 2000, what is the difference between the Area (in %) of Bolivia and Area (in %) of Moldova?
Your response must be concise. -43.09. In the year 2000, what is the difference between the Area (in %) in Bolivia and Area (in %) in Oman?
Offer a very short reply. 30.5. In the year 2000, what is the difference between the Area (in %) in Bolivia and Area (in %) in Palau?
Your answer should be very brief. 23.42. In the year 2000, what is the difference between the Area (in %) of Moldova and Area (in %) of Oman?
Offer a terse response. 73.58. In the year 2000, what is the difference between the Area (in %) in Moldova and Area (in %) in Palau?
Provide a short and direct response. 66.5. In the year 2000, what is the difference between the Area (in %) of Oman and Area (in %) of Palau?
Offer a very short reply. -7.08. What is the ratio of the Area (in %) in Bolivia in 1993 to that in 1994?
Your response must be concise. 1. What is the ratio of the Area (in %) of Moldova in 1993 to that in 1994?
Provide a succinct answer. 1. What is the ratio of the Area (in %) of Oman in 1993 to that in 1994?
Keep it short and to the point. 1. What is the ratio of the Area (in %) of Bolivia in 1993 to that in 1995?
Your response must be concise. 0.99. What is the ratio of the Area (in %) of Moldova in 1993 to that in 1995?
Give a very brief answer. 1. What is the ratio of the Area (in %) in Bolivia in 1993 to that in 1996?
Provide a succinct answer. 0.99. What is the ratio of the Area (in %) of Moldova in 1993 to that in 1996?
Your answer should be very brief. 1. What is the ratio of the Area (in %) of Oman in 1993 to that in 1996?
Your response must be concise. 1. What is the ratio of the Area (in %) of Bolivia in 1993 to that in 1997?
Give a very brief answer. 0.98. What is the ratio of the Area (in %) of Moldova in 1993 to that in 1997?
Offer a very short reply. 1. What is the ratio of the Area (in %) in Palau in 1993 to that in 1997?
Offer a terse response. 1. What is the ratio of the Area (in %) of Bolivia in 1993 to that in 1998?
Your response must be concise. 0.98. What is the ratio of the Area (in %) of Moldova in 1993 to that in 1998?
Provide a short and direct response. 1. What is the ratio of the Area (in %) in Oman in 1993 to that in 1998?
Give a very brief answer. 1. What is the ratio of the Area (in %) of Palau in 1993 to that in 1998?
Provide a short and direct response. 1. What is the ratio of the Area (in %) in Bolivia in 1993 to that in 1999?
Provide a succinct answer. 0.98. What is the ratio of the Area (in %) in Oman in 1993 to that in 1999?
Your response must be concise. 1. What is the ratio of the Area (in %) in Palau in 1993 to that in 1999?
Your answer should be very brief. 1. What is the ratio of the Area (in %) in Moldova in 1993 to that in 2000?
Provide a short and direct response. 1. What is the ratio of the Area (in %) in Oman in 1993 to that in 2000?
Make the answer very short. 0.91. What is the ratio of the Area (in %) of Palau in 1993 to that in 2000?
Your response must be concise. 1. What is the ratio of the Area (in %) of Moldova in 1994 to that in 1995?
Provide a succinct answer. 1. What is the ratio of the Area (in %) of Oman in 1994 to that in 1995?
Provide a succinct answer. 1. What is the ratio of the Area (in %) of Bolivia in 1994 to that in 1996?
Offer a very short reply. 0.99. What is the ratio of the Area (in %) in Moldova in 1994 to that in 1996?
Give a very brief answer. 1. What is the ratio of the Area (in %) of Palau in 1994 to that in 1996?
Provide a succinct answer. 1. What is the ratio of the Area (in %) in Bolivia in 1994 to that in 1997?
Provide a succinct answer. 0.99. What is the ratio of the Area (in %) of Moldova in 1994 to that in 1997?
Make the answer very short. 1. What is the ratio of the Area (in %) of Oman in 1994 to that in 1997?
Make the answer very short. 1. What is the ratio of the Area (in %) in Bolivia in 1994 to that in 1998?
Your answer should be compact. 0.98. What is the ratio of the Area (in %) in Oman in 1994 to that in 1998?
Your answer should be very brief. 1. What is the ratio of the Area (in %) in Palau in 1994 to that in 1998?
Your answer should be compact. 1. What is the ratio of the Area (in %) in Bolivia in 1994 to that in 1999?
Provide a short and direct response. 0.98. What is the ratio of the Area (in %) of Moldova in 1994 to that in 1999?
Keep it short and to the point. 1. What is the ratio of the Area (in %) of Oman in 1994 to that in 1999?
Give a very brief answer. 1. What is the ratio of the Area (in %) in Palau in 1994 to that in 1999?
Your response must be concise. 1. What is the ratio of the Area (in %) of Bolivia in 1994 to that in 2000?
Offer a very short reply. 0.98. What is the ratio of the Area (in %) in Oman in 1994 to that in 2000?
Give a very brief answer. 0.91. What is the ratio of the Area (in %) in Oman in 1995 to that in 1996?
Ensure brevity in your answer.  1. What is the ratio of the Area (in %) of Moldova in 1995 to that in 1997?
Your response must be concise. 1. What is the ratio of the Area (in %) of Palau in 1995 to that in 1997?
Your answer should be very brief. 1. What is the ratio of the Area (in %) of Oman in 1995 to that in 1998?
Make the answer very short. 1. What is the ratio of the Area (in %) of Palau in 1995 to that in 1998?
Offer a very short reply. 1. What is the ratio of the Area (in %) of Bolivia in 1995 to that in 1999?
Provide a succinct answer. 0.99. What is the ratio of the Area (in %) of Oman in 1995 to that in 1999?
Make the answer very short. 1. What is the ratio of the Area (in %) in Palau in 1995 to that in 1999?
Offer a very short reply. 1. What is the ratio of the Area (in %) in Bolivia in 1995 to that in 2000?
Make the answer very short. 0.99. What is the ratio of the Area (in %) of Bolivia in 1996 to that in 1998?
Your answer should be very brief. 0.99. What is the ratio of the Area (in %) in Moldova in 1996 to that in 1998?
Offer a very short reply. 1. What is the ratio of the Area (in %) of Palau in 1996 to that in 1998?
Offer a terse response. 1. What is the ratio of the Area (in %) in Bolivia in 1996 to that in 1999?
Your response must be concise. 0.99. What is the ratio of the Area (in %) of Moldova in 1996 to that in 1999?
Provide a succinct answer. 1. What is the ratio of the Area (in %) in Oman in 1996 to that in 1999?
Your answer should be very brief. 1. What is the ratio of the Area (in %) in Palau in 1996 to that in 1999?
Your answer should be compact. 1. What is the ratio of the Area (in %) of Bolivia in 1996 to that in 2000?
Keep it short and to the point. 0.99. What is the ratio of the Area (in %) in Moldova in 1996 to that in 2000?
Offer a very short reply. 1. What is the ratio of the Area (in %) of Palau in 1996 to that in 2000?
Your answer should be compact. 1. What is the ratio of the Area (in %) in Bolivia in 1997 to that in 1998?
Keep it short and to the point. 1. What is the ratio of the Area (in %) in Palau in 1997 to that in 1998?
Ensure brevity in your answer.  1. What is the ratio of the Area (in %) in Bolivia in 1997 to that in 1999?
Offer a terse response. 0.99. What is the ratio of the Area (in %) of Oman in 1997 to that in 1999?
Offer a very short reply. 1. What is the ratio of the Area (in %) of Bolivia in 1997 to that in 2000?
Your answer should be very brief. 0.99. What is the ratio of the Area (in %) of Oman in 1997 to that in 2000?
Ensure brevity in your answer.  0.91. What is the ratio of the Area (in %) of Palau in 1997 to that in 2000?
Your response must be concise. 1. What is the ratio of the Area (in %) of Oman in 1998 to that in 2000?
Make the answer very short. 0.91. What is the ratio of the Area (in %) of Moldova in 1999 to that in 2000?
Give a very brief answer. 1. What is the difference between the highest and the second highest Area (in %) in Bolivia?
Give a very brief answer. 0.07. What is the difference between the highest and the second highest Area (in %) in Moldova?
Keep it short and to the point. 0.05. What is the difference between the highest and the second highest Area (in %) in Oman?
Ensure brevity in your answer.  0.33. What is the difference between the highest and the lowest Area (in %) in Bolivia?
Your answer should be compact. 0.86. What is the difference between the highest and the lowest Area (in %) in Moldova?
Give a very brief answer. 0.35. What is the difference between the highest and the lowest Area (in %) of Oman?
Ensure brevity in your answer.  0.33. 